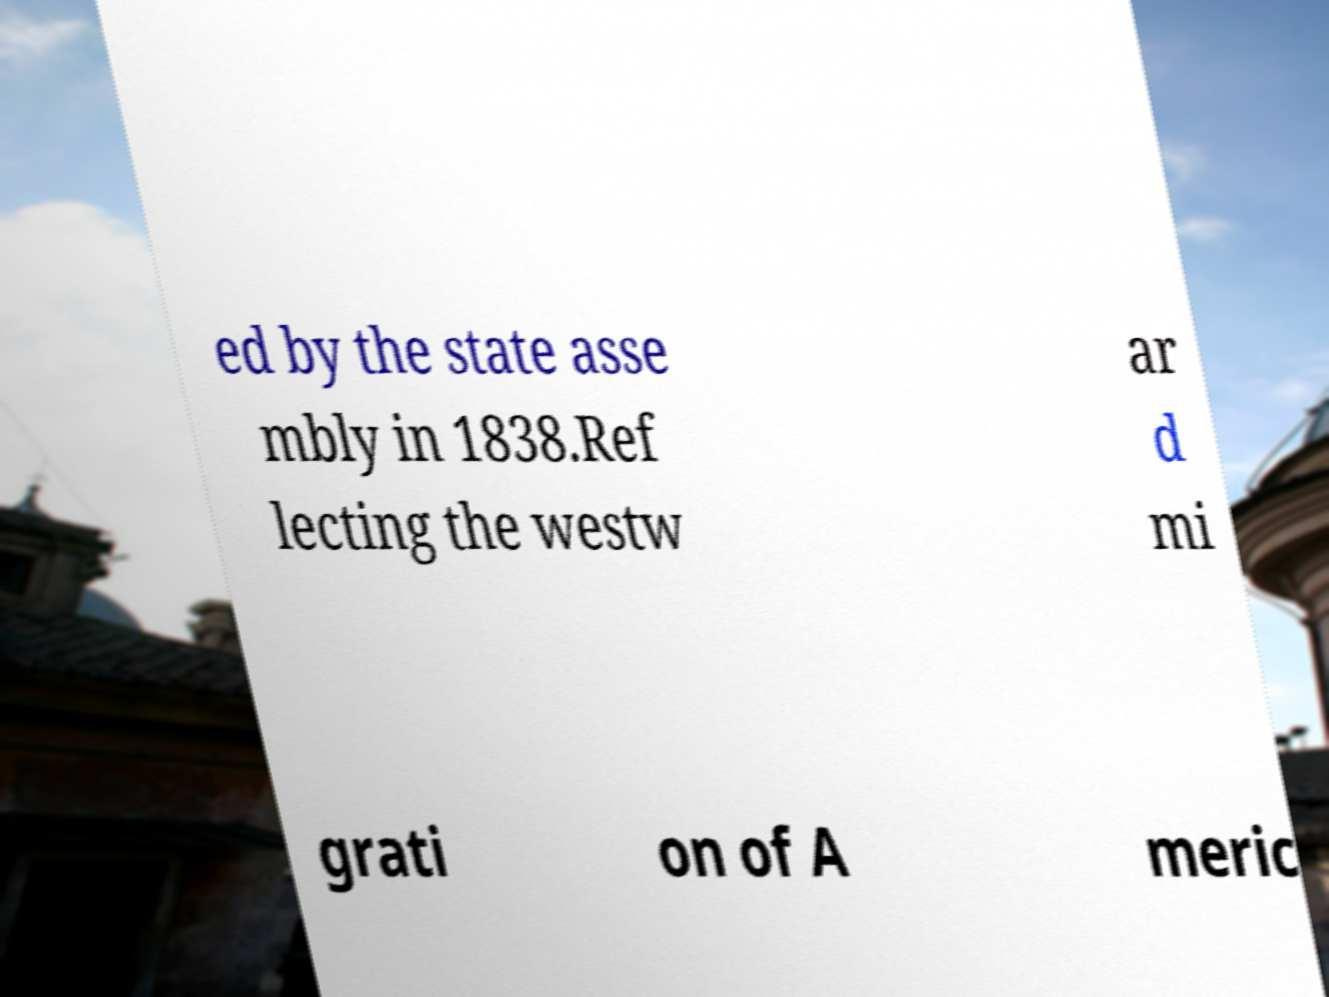Can you read and provide the text displayed in the image?This photo seems to have some interesting text. Can you extract and type it out for me? ed by the state asse mbly in 1838.Ref lecting the westw ar d mi grati on of A meric 